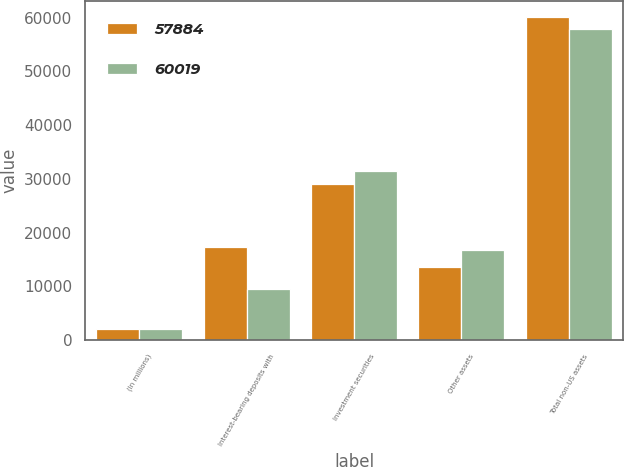<chart> <loc_0><loc_0><loc_500><loc_500><stacked_bar_chart><ecel><fcel>(In millions)<fcel>Interest-bearing deposits with<fcel>Investment securities<fcel>Other assets<fcel>Total non-US assets<nl><fcel>57884<fcel>2014<fcel>17382<fcel>29060<fcel>13577<fcel>60019<nl><fcel>60019<fcel>2013<fcel>9584<fcel>31522<fcel>16778<fcel>57884<nl></chart> 